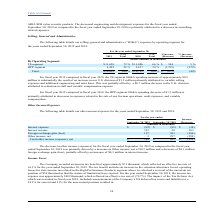According to Csp's financial document, When does the company's fiscal year end? According to the financial document, September 30. The relevant text states: "nd development expenses for the fiscal year ended September 30, 2019 as compared to the fiscal year ended September 30, 2018 is primarily attributed to a decrease..." Also, What is the company's total net income in 2019? According to the financial document, $384 (in thousands). The relevant text states: "Total other income (expense), net $ 384 $ 495 $ (111)..." Also, What caused the decrease in income between 2018 and 2019? A decrease in Other income. The document states: "ended September 30, 2018 was primarily driven by a decrease in Other income, net of $0.3 million and a decrease of $0.1 million foreign exchange gain ..." Also, can you calculate: What is the company's percentage change in total other income between 2018 and 2019? To answer this question, I need to perform calculations using the financial data. The calculation is: - $111/$495 * 1 , which equals -22.42 (percentage). This is based on the information: "Total other income (expense), net $ 384 $ 495 $ (111) Total other income (expense), net $ 384 $ 495 $ (111) Total other income (expense), net $ 384 $ 495 $ (111)..." The key data points involved are: 1, 111, 495. Also, can you calculate: What is the company's net interest expense in 2018? Based on the calculation: -$85 + 20 , the result is -65 (in thousands). This is based on the information: "Interest expense $ (99) $ (85) $ (14) t expenses for the fiscal year ended September 30, 2019 as compared to the fiscal year ended September 30, 2018 is primarily attributed to a decrease in..." The key data points involved are: 20, 85. Also, can you calculate: What percentage of the company's 2019 total other income is the foreign exchange gain? To answer this question, I need to perform calculations using the financial data. The calculation is: 157/384 * 1 , which equals 40.89 (percentage). This is based on the information: "Total other income (expense), net $ 384 $ 495 $ (111) Foreign exchange gain (loss) 157 263 (106) Foreign exchange gain (loss) 157 263 (106)..." The key data points involved are: 1, 157, 384. 